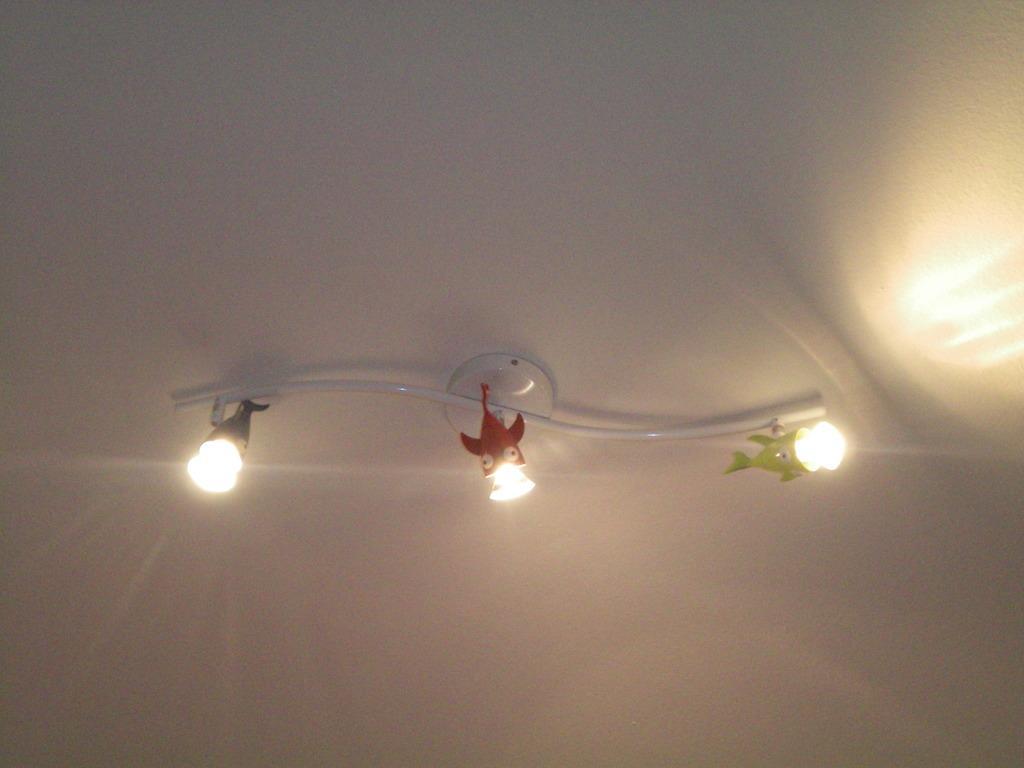Can you describe this image briefly? In the image there are lights on the ceiling to a hanger. 